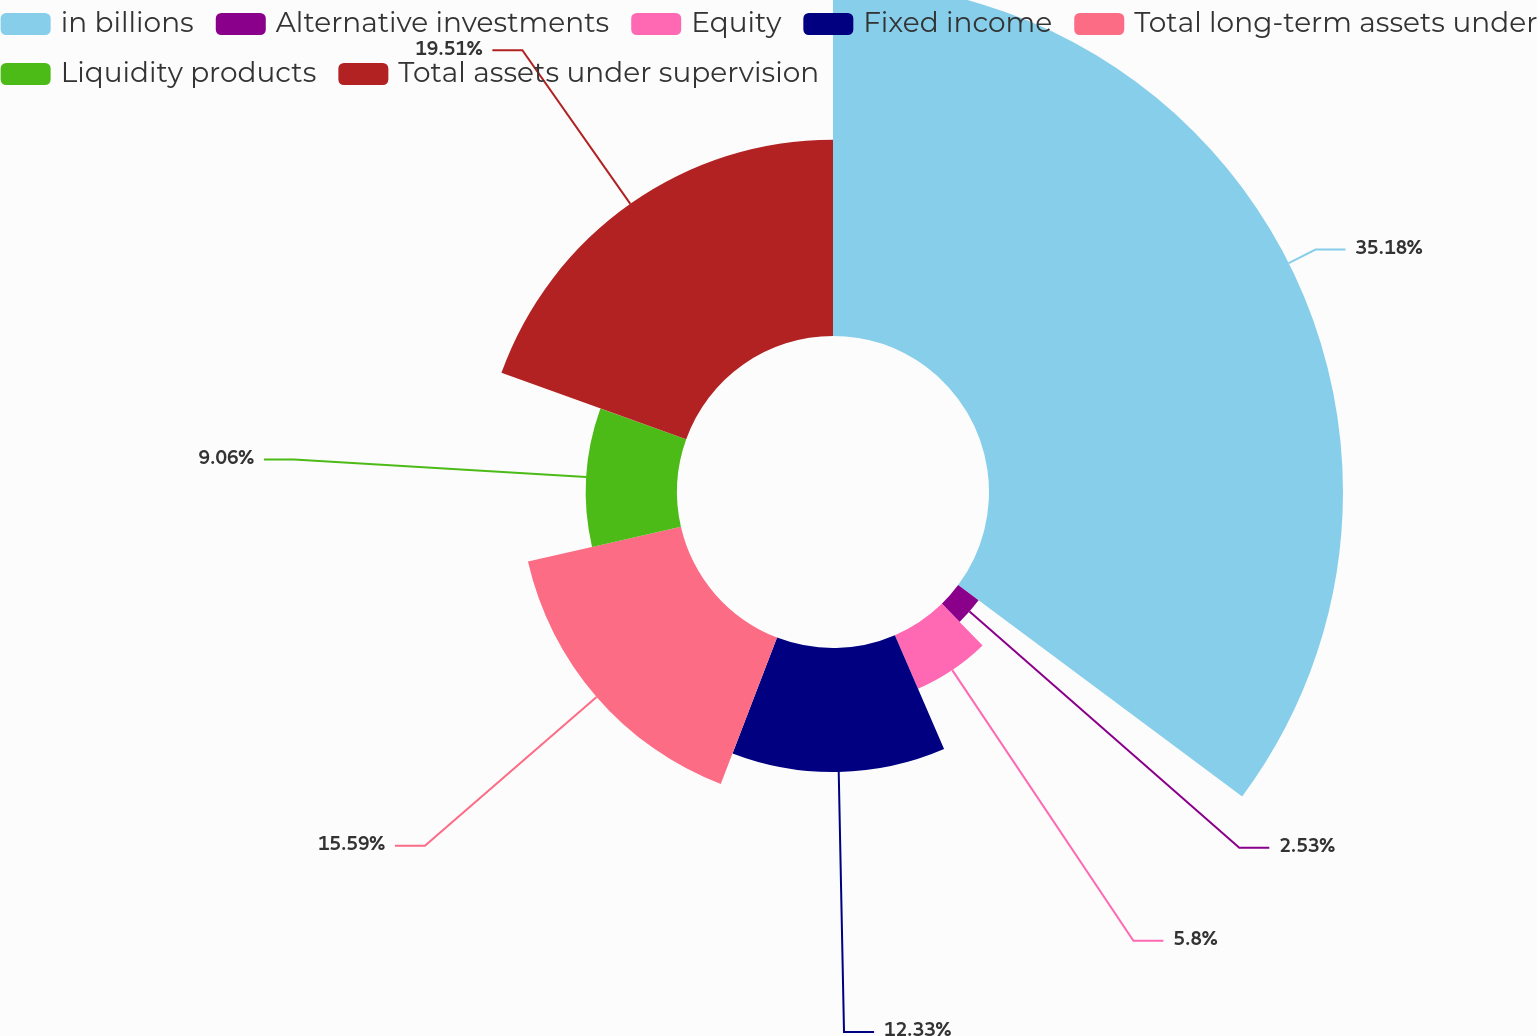<chart> <loc_0><loc_0><loc_500><loc_500><pie_chart><fcel>in billions<fcel>Alternative investments<fcel>Equity<fcel>Fixed income<fcel>Total long-term assets under<fcel>Liquidity products<fcel>Total assets under supervision<nl><fcel>35.18%<fcel>2.53%<fcel>5.8%<fcel>12.33%<fcel>15.59%<fcel>9.06%<fcel>19.51%<nl></chart> 